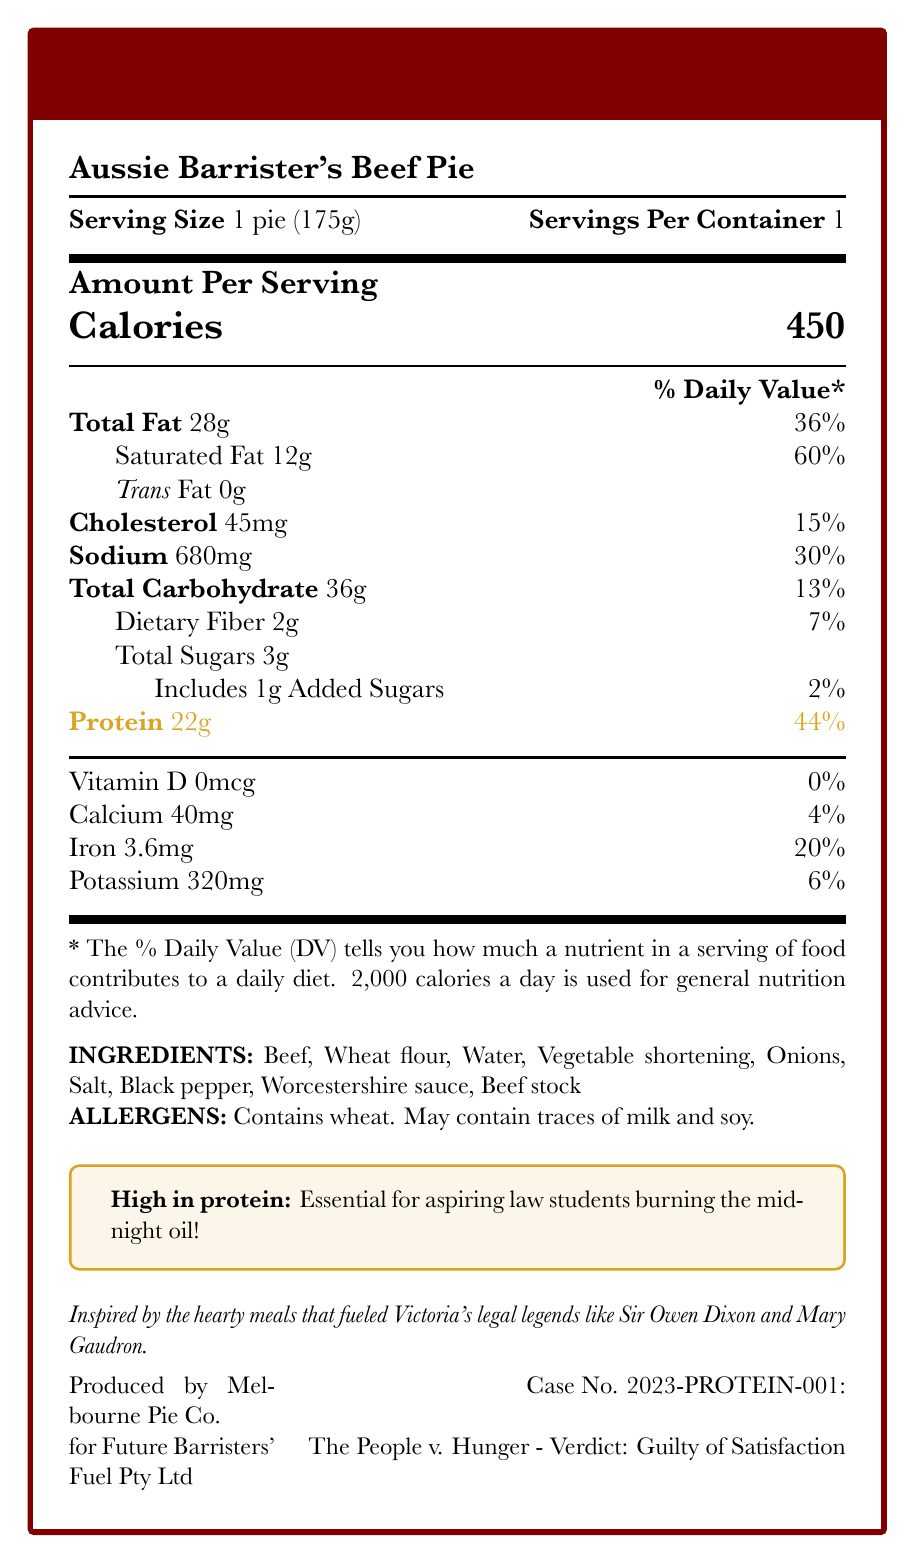what is the serving size of the Aussie Barrister's Beef Pie? The document states that the serving size is 1 pie (175g).
Answer: 1 pie (175g) how many grams of protein are in one serving? The Nutrition Facts section highlights that there are 22 grams of protein in one serving.
Answer: 22g what percentage of the daily value for saturated fat does one pie provide? The document indicates that one pie has 60% of the daily value for saturated fat.
Answer: 60% how much sodium is in one serving of the meat pie? The Nutrition Facts section lists 680mg of sodium per serving.
Answer: 680mg what are the main ingredients in the Aussie Barrister's Beef Pie? The Ingredients section lists these as the main ingredients.
Answer: Beef, Wheat flour, Water, Vegetable shortening, Onions, Salt, Black pepper, Worcestershire sauce, Beef stock which nutrient is present in the highest amount by weight per serving? A. Total Fat B. Total Carbohydrate C. Protein D. Sodium Total fat is 28g, which is higher than other listed nutrients by weight per serving.
Answer: A. Total Fat what is the percentage daily value of iron in one serving? A. 4% B. 6% C. 20% D. 30% The Nutrition Facts section states that the iron content in one serving is 3.6mg, which is 20% of the daily value.
Answer: C. 20% is there any trans fat in one serving of the meat pie? The Nutrition Facts Label indicates that there are 0g of trans fat.
Answer: No does the pie contain any allergens? Contains wheat, and may contain traces of milk and soy.
Answer: Yes what is the main appeal or marketing tagline of this product? This tagline is highlighted in the document under Nutrition Highlight.
Answer: High in protein: Essential for aspiring law students burning the midnight oil! what type of diet are the daily values in this document based on? The legal note specifies that the percent daily values are based on a 2,000 calorie diet.
Answer: 2,000 calorie diet how many calories does one serving of the pie provide? The Nutrition Facts section lists the calorie content as 450 per serving.
Answer: 450 which company produces the Aussie Barrister's Beef Pie? The manufacturer information states this.
Answer: Melbourne Pie Co. for Future Barristers' Fuel Pty Ltd what is the legal appeal mentioned in the document related to the product? The document includes this legal appeal under the manufacturer's details.
Answer: Case No. 2023-PROTEIN-001: The People v. Hunger - Verdict: Guilty of Satisfaction what is the cholesterol content in one serving, and what is its daily value percentage? The document specifies that one serving contains 45mg of cholesterol, which is 15% of the daily value.
Answer: 45mg, 15% summarize the main idea of this document. The document provides detailed nutritional information about the Aussie Barrister's Beef Pie, emphasizing its high protein content, and includes ingredient and allergen details, as well as a marketing appeal aimed at aspiring law students.
Answer: The document is a nutrition facts label for a traditional Australian meat pie called the Aussie Barrister's Beef Pie. It highlights the nutritional content per serving, including calories, fats, cholesterol, sodium, carbohydrates, and protein, with an emphasis on its high protein content. It also lists the ingredients, potential allergens, manufacturer information, and a marketing tagline targeting law students. what are the origins of the meal’s inspiration mentioned in the branding statement? The brand statement specifies that the meal is inspired by the hearty meals of Victoria's legal legends.
Answer: Inspired by the hearty meals that fueled Victoria's legal legends like Sir Owen Dixon and Mary Gaudron. how many grams of sugar, including added sugars, are in one serving? The document lists 3g of total sugars and 1g of added sugars.
Answer: 3g total sugars, including 1g added sugars what kind of calorie needs might alter the percent daily values? The document notes that daily values may be higher or lower depending on individual calorie needs.
Answer: Higher or lower calorie needs are there any traces of soy in the product? The allergen information mentions that the product may contain traces of soy.
Answer: May contain traces of soy can you determine the cooking instructions for the meat pie from this document? The document does not provide any cooking instructions.
Answer: Cannot be determined 